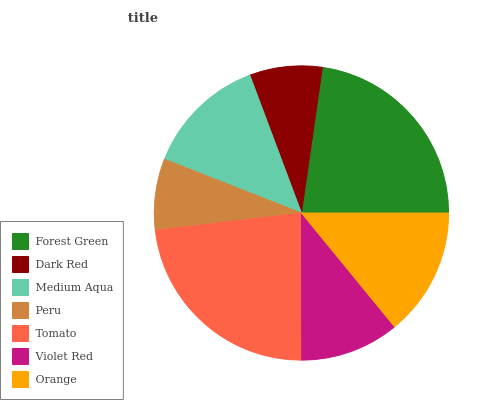Is Peru the minimum?
Answer yes or no. Yes. Is Tomato the maximum?
Answer yes or no. Yes. Is Dark Red the minimum?
Answer yes or no. No. Is Dark Red the maximum?
Answer yes or no. No. Is Forest Green greater than Dark Red?
Answer yes or no. Yes. Is Dark Red less than Forest Green?
Answer yes or no. Yes. Is Dark Red greater than Forest Green?
Answer yes or no. No. Is Forest Green less than Dark Red?
Answer yes or no. No. Is Medium Aqua the high median?
Answer yes or no. Yes. Is Medium Aqua the low median?
Answer yes or no. Yes. Is Violet Red the high median?
Answer yes or no. No. Is Peru the low median?
Answer yes or no. No. 